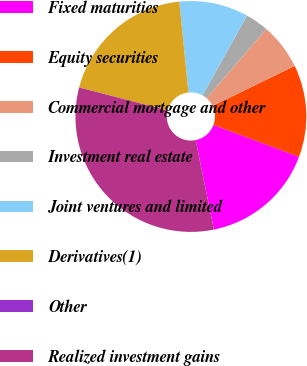<chart> <loc_0><loc_0><loc_500><loc_500><pie_chart><fcel>Fixed maturities<fcel>Equity securities<fcel>Commercial mortgage and other<fcel>Investment real estate<fcel>Joint ventures and limited<fcel>Derivatives(1)<fcel>Other<fcel>Realized investment gains<nl><fcel>16.12%<fcel>12.9%<fcel>6.46%<fcel>3.24%<fcel>9.68%<fcel>19.35%<fcel>0.01%<fcel>32.23%<nl></chart> 